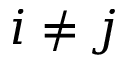Convert formula to latex. <formula><loc_0><loc_0><loc_500><loc_500>i \neq j</formula> 